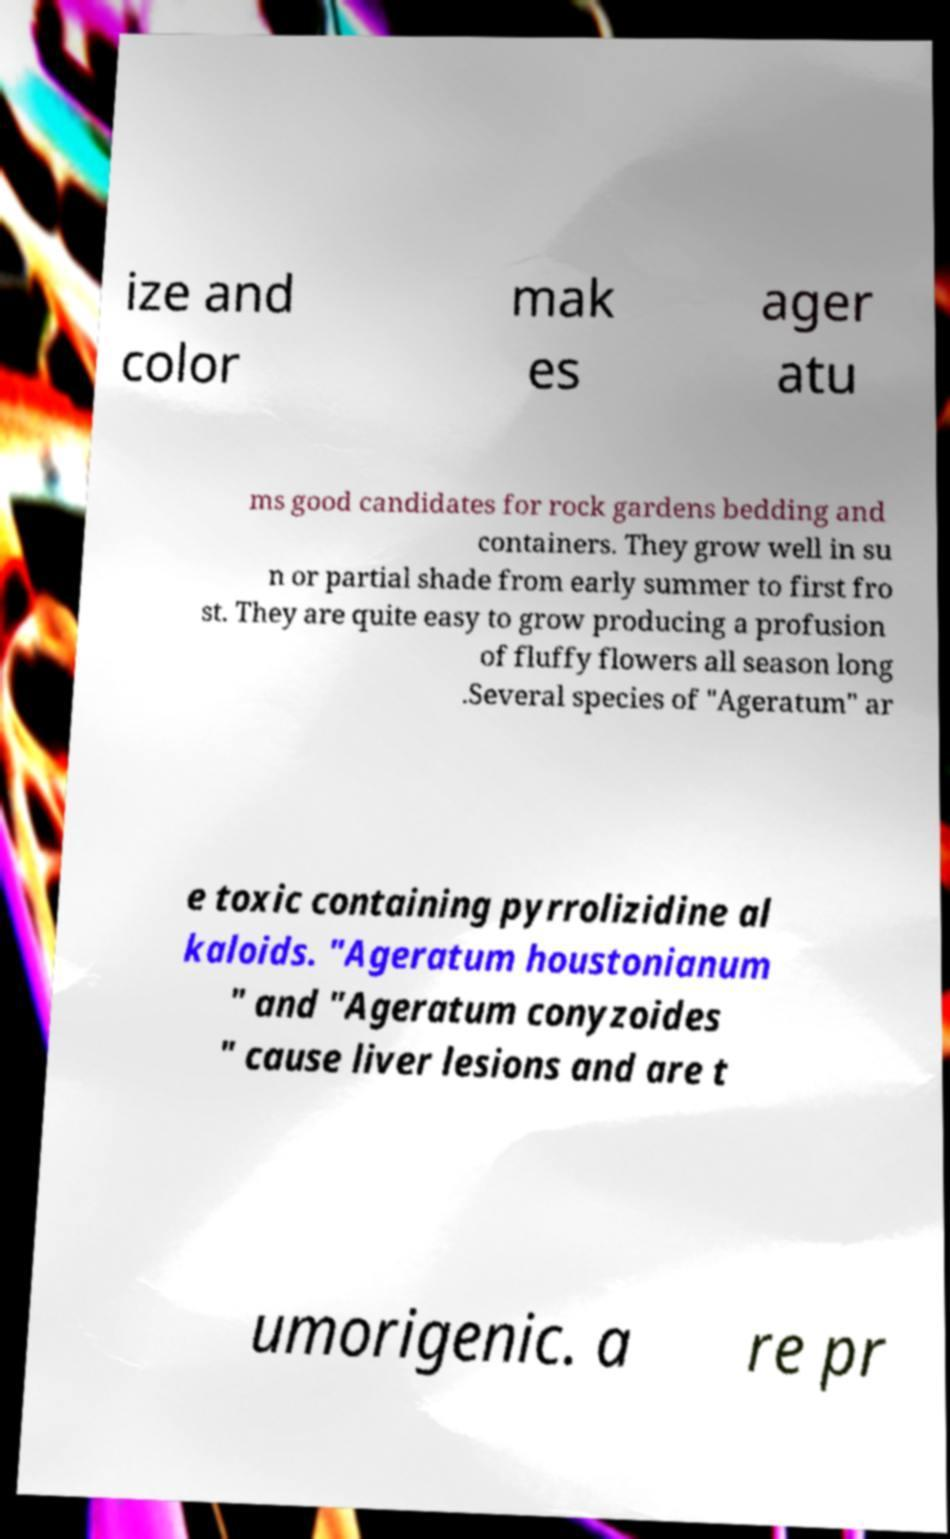Can you accurately transcribe the text from the provided image for me? ize and color mak es ager atu ms good candidates for rock gardens bedding and containers. They grow well in su n or partial shade from early summer to first fro st. They are quite easy to grow producing a profusion of fluffy flowers all season long .Several species of "Ageratum" ar e toxic containing pyrrolizidine al kaloids. "Ageratum houstonianum " and "Ageratum conyzoides " cause liver lesions and are t umorigenic. a re pr 